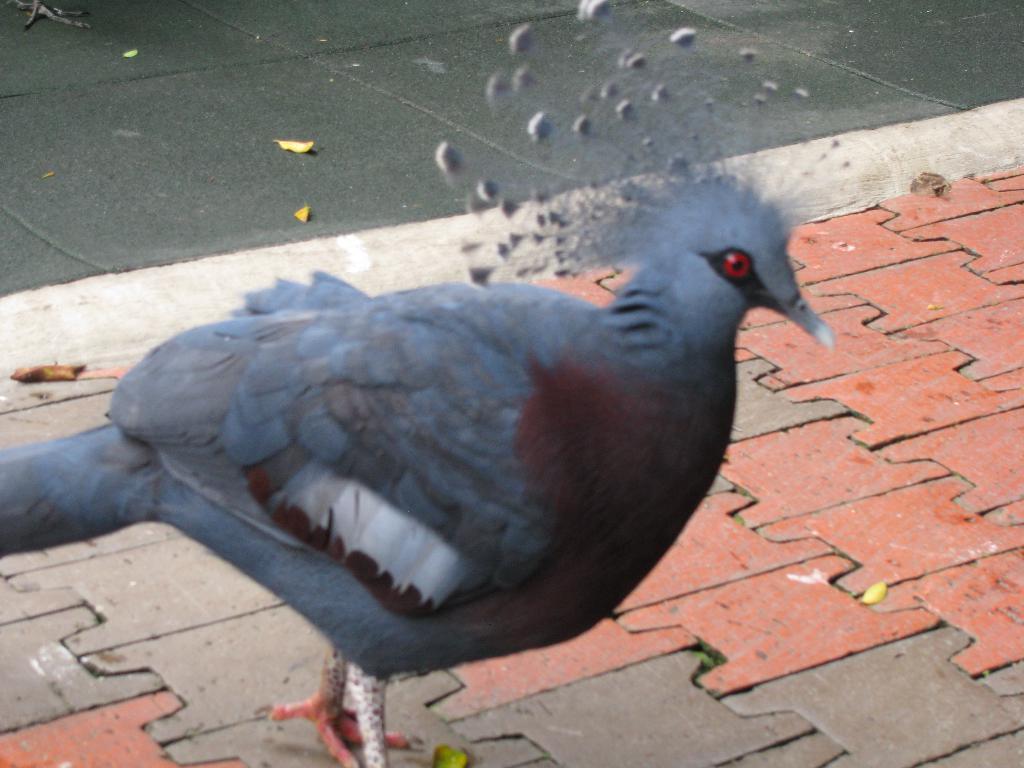In one or two sentences, can you explain what this image depicts? In this picture I can see a bird is standing on the ground. In the background I can see leaves. 